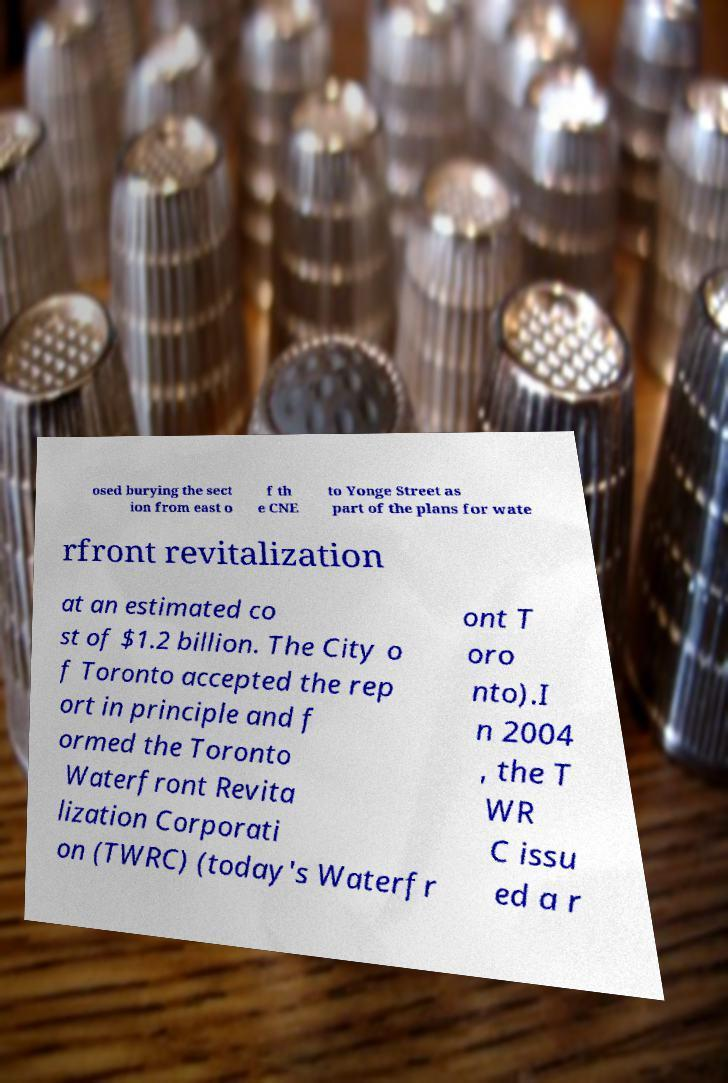What messages or text are displayed in this image? I need them in a readable, typed format. osed burying the sect ion from east o f th e CNE to Yonge Street as part of the plans for wate rfront revitalization at an estimated co st of $1.2 billion. The City o f Toronto accepted the rep ort in principle and f ormed the Toronto Waterfront Revita lization Corporati on (TWRC) (today's Waterfr ont T oro nto).I n 2004 , the T WR C issu ed a r 